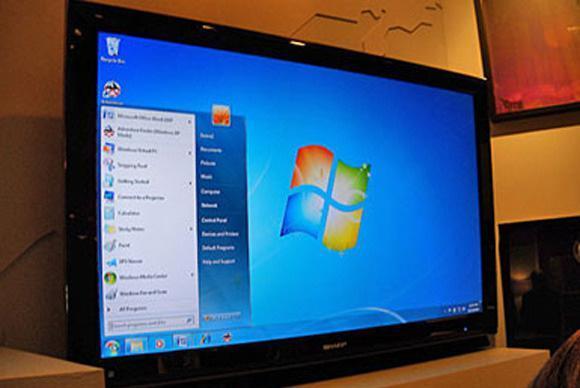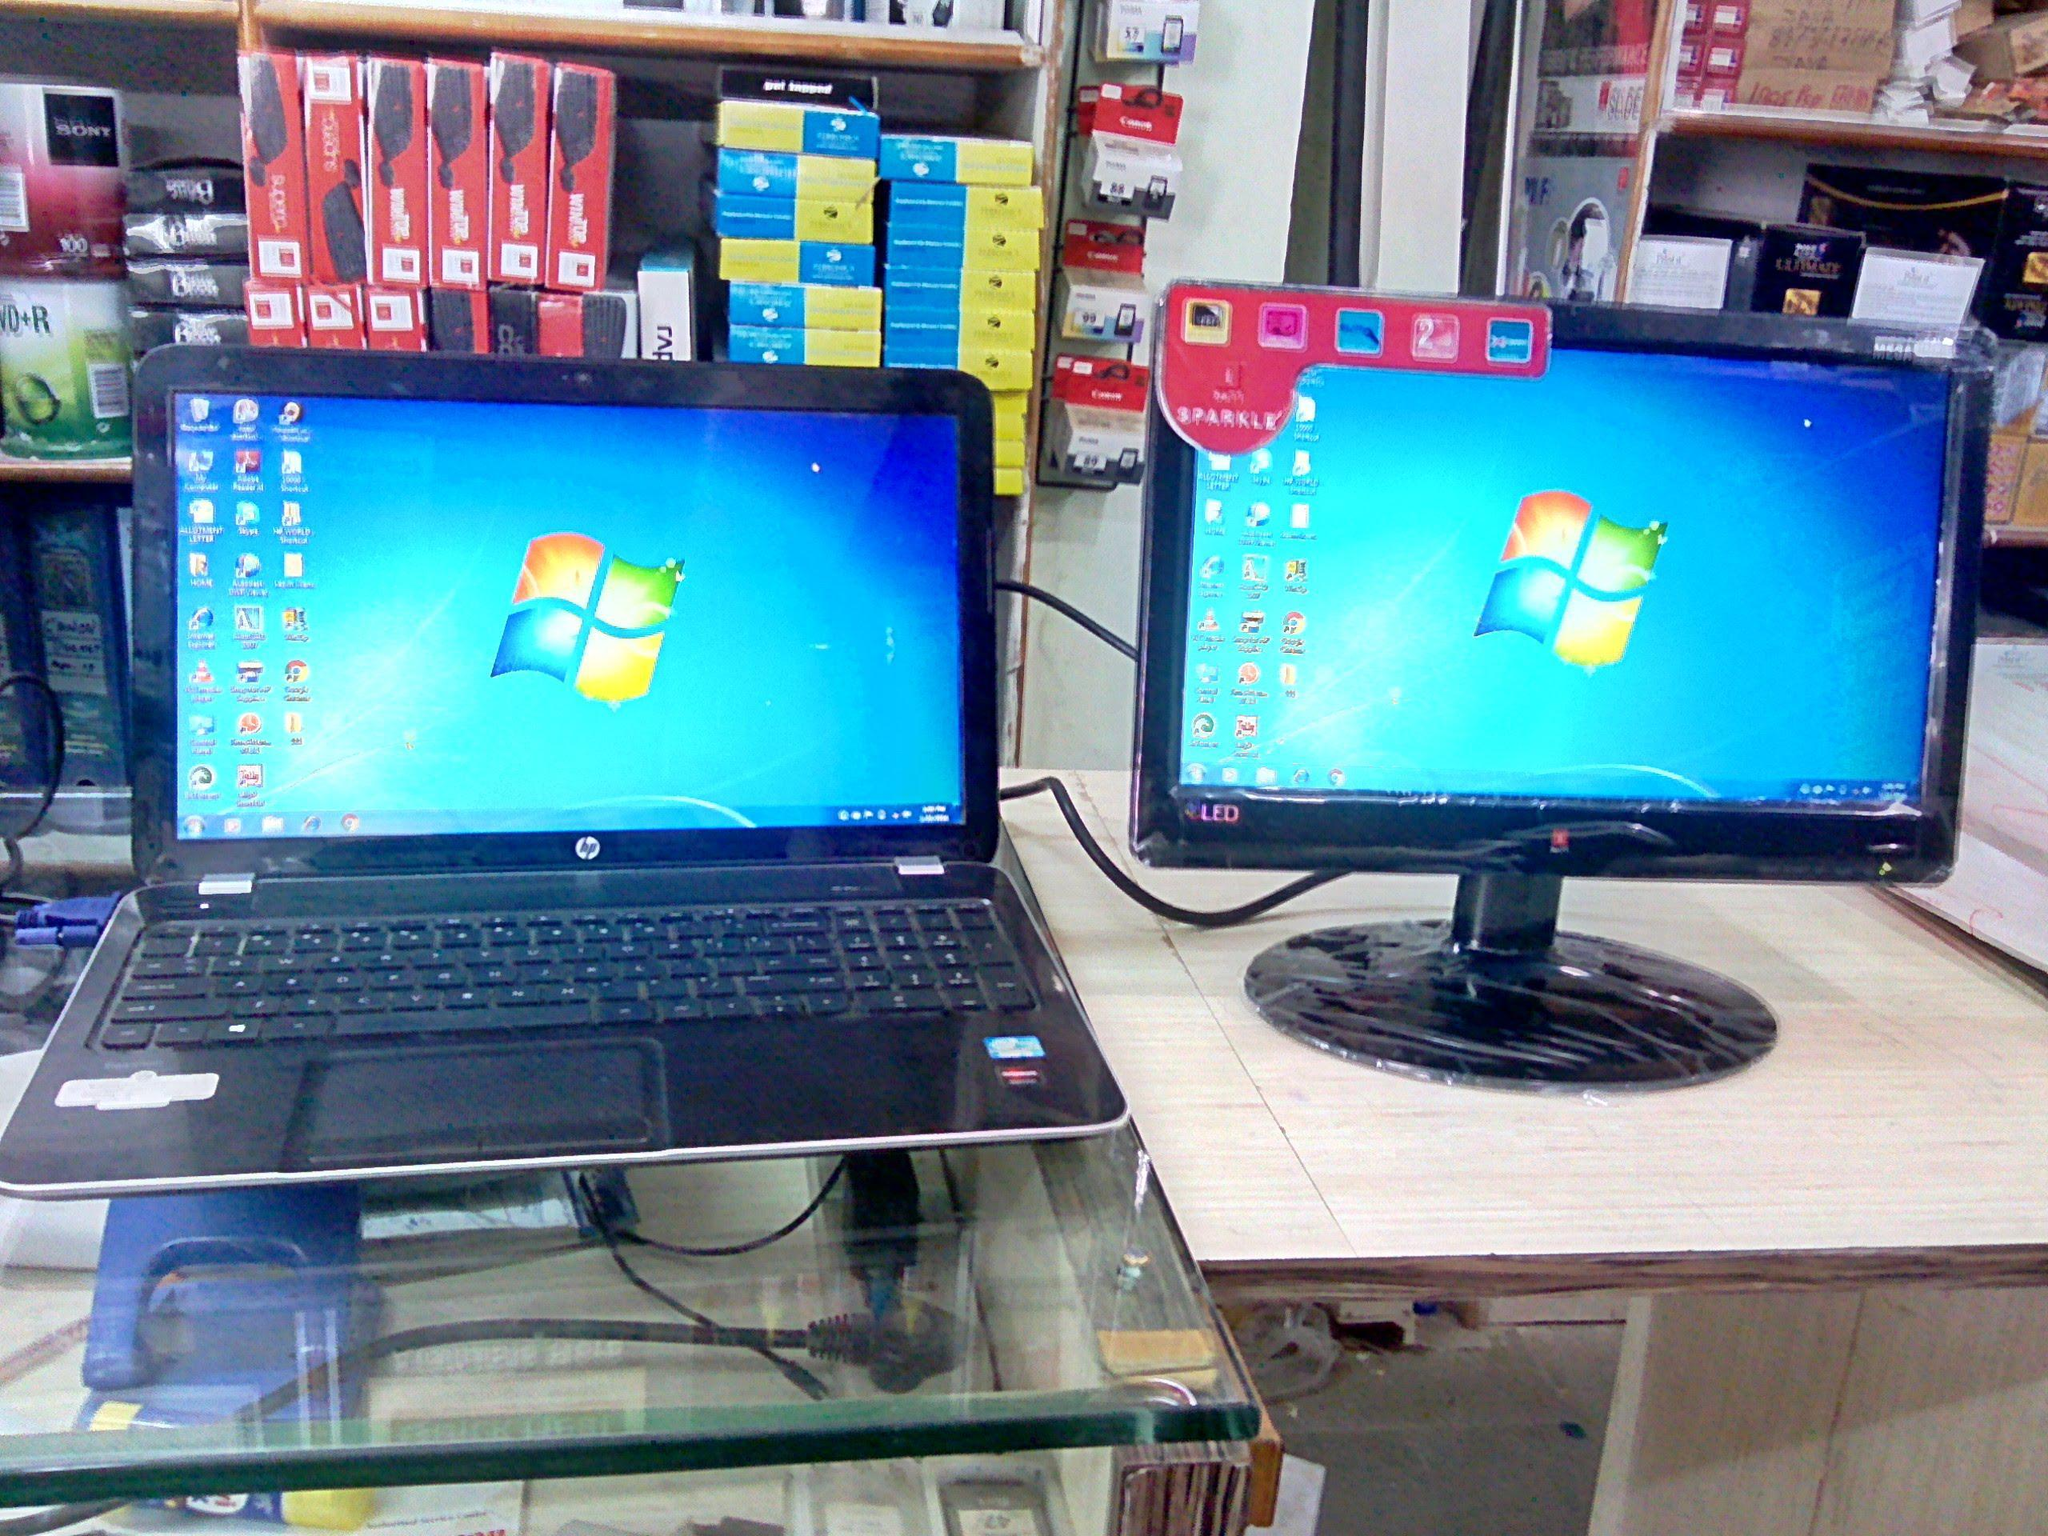The first image is the image on the left, the second image is the image on the right. Considering the images on both sides, is "The desktop is visible on the screen." valid? Answer yes or no. Yes. 